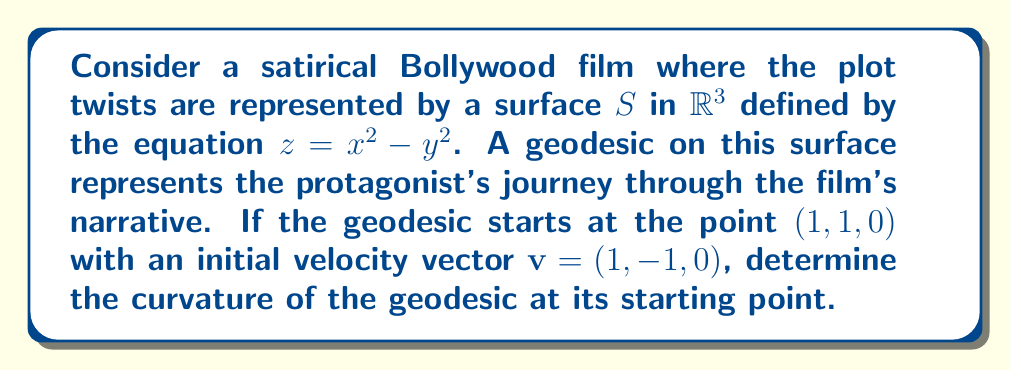Can you solve this math problem? To find the curvature of the geodesic at its starting point, we need to follow these steps:

1) First, we need to calculate the first and second fundamental forms of the surface. The surface is given by $z = x^2 - y^2$.

2) The parametrization of the surface is:
   $\mathbf{r}(x, y) = (x, y, x^2 - y^2)$

3) Calculate the partial derivatives:
   $\mathbf{r}_x = (1, 0, 2x)$
   $\mathbf{r}_y = (0, 1, -2y)$

4) The coefficients of the first fundamental form are:
   $E = \mathbf{r}_x \cdot \mathbf{r}_x = 1 + 4x^2$
   $F = \mathbf{r}_x \cdot \mathbf{r}_y = 0$
   $G = \mathbf{r}_y \cdot \mathbf{r}_y = 1 + 4y^2$

5) The unit normal vector to the surface is:
   $$\mathbf{N} = \frac{\mathbf{r}_x \times \mathbf{r}_y}{|\mathbf{r}_x \times \mathbf{r}_y|} = \frac{(-2x, 2y, 1)}{\sqrt{1 + 4x^2 + 4y^2}}$$

6) The coefficients of the second fundamental form are:
   $L = \mathbf{N} \cdot \mathbf{r}_{xx} = \frac{2}{\sqrt{1 + 4x^2 + 4y^2}}$
   $M = \mathbf{N} \cdot \mathbf{r}_{xy} = 0$
   $N = \mathbf{N} \cdot \mathbf{r}_{yy} = \frac{-2}{\sqrt{1 + 4x^2 + 4y^2}}$

7) The geodesic curvature $\kappa_g$ is zero for a geodesic. The normal curvature $\kappa_n$ in the direction of $\mathbf{v} = (1, -1, 0)$ at the point $(1, 1, 0)$ is:

   $$\kappa_n = \frac{L dx^2 + 2M dx dy + N dy^2}{E dx^2 + 2F dx dy + G dy^2} = \frac{2 - 2}{5 + 5} = 0$$

8) The geodesic torsion $\tau_g$ is:

   $$\tau_g = \frac{(EN - GL) dx dy + FM(dx^2 - dy^2)}{(E dx^2 + 2F dx dy + G dy^2)\sqrt{EG - F^2}} = \frac{(5 \cdot (-2) - 5 \cdot 2) \cdot 1 \cdot (-1)}{(5 \cdot 1^2 + 5 \cdot (-1)^2)\sqrt{5 \cdot 5 - 0^2}} = \frac{2\sqrt{5}}{5}$$

9) The curvature $\kappa$ of the geodesic is given by:
   $$\kappa = \sqrt{\kappa_n^2 + \tau_g^2} = \sqrt{0^2 + (\frac{2\sqrt{5}}{5})^2} = \frac{2\sqrt{5}}{5}$$
Answer: $\frac{2\sqrt{5}}{5}$ 